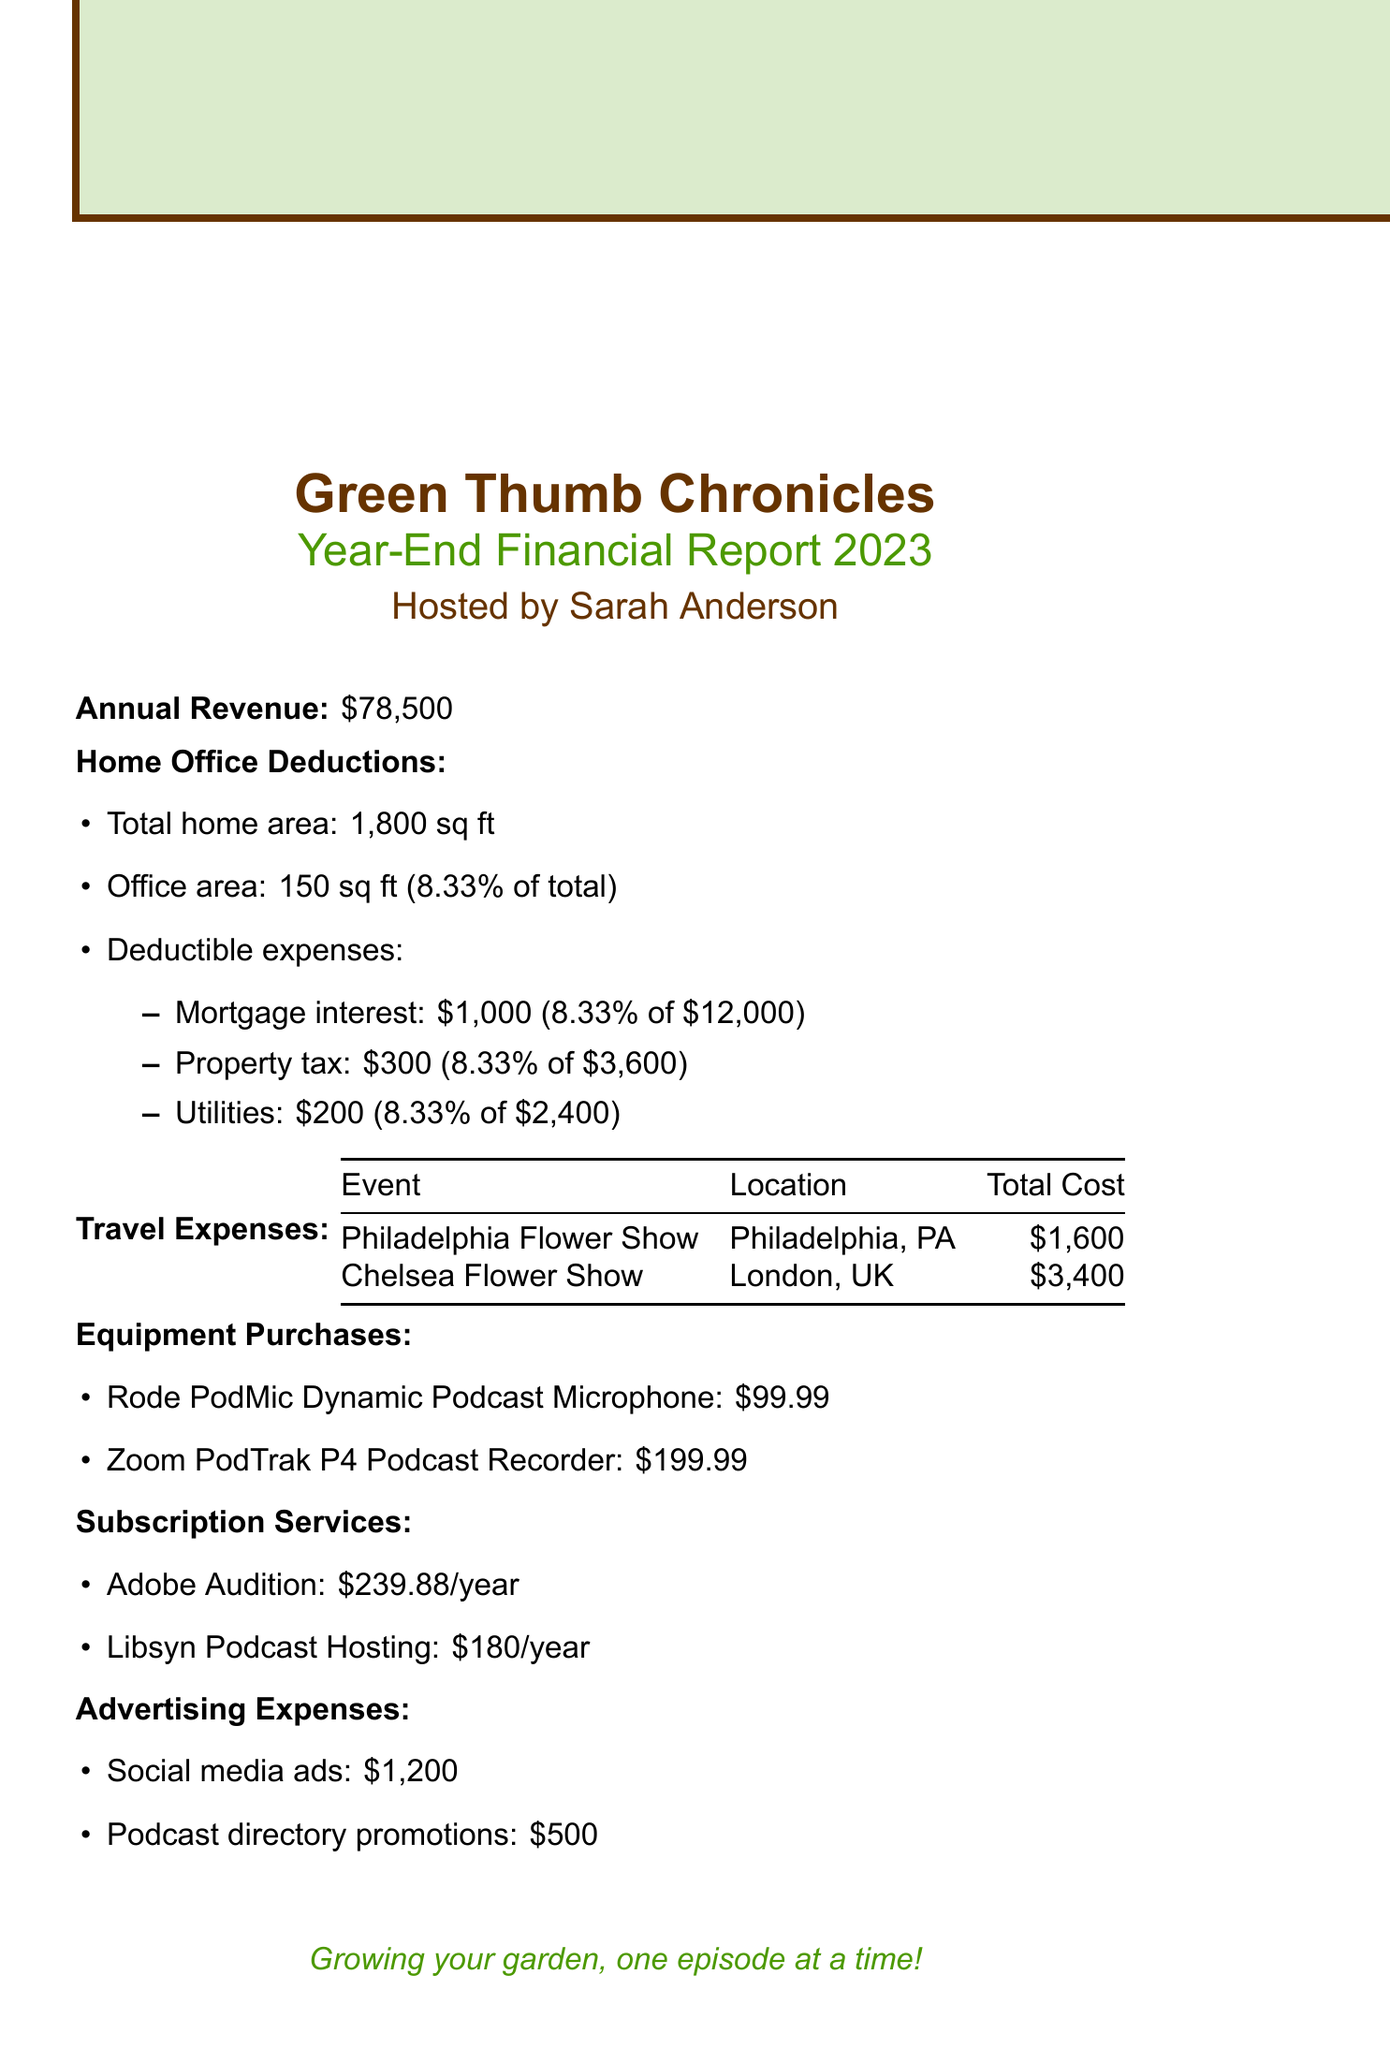What is the name of the podcast? The name of the podcast is stated at the beginning of the document under the header.
Answer: Green Thumb Chronicles What was the annual revenue for 2023? The annual revenue is explicitly listed in the financial report.
Answer: $78,500 What percentage of the total home area is the office area? The document specifies the total area and the office area, and calculates the percentage.
Answer: 8.33% How much was spent on airfare for the Chelsea Flower Show? The airfare expense for the Chelsea Flower Show is given in the travel expenses section.
Answer: $1,200 What are the total travel expenses for the Philadelphia Flower Show? The document lists individual expenses and provides a total cost for the event.
Answer: $1,600 How much did the podcast spend on the Rode PodMic? The cost of the Rode PodMic is mentioned in the equipment purchases.
Answer: $99.99 What is the total cost of annual subscription services? The document specifies individual annual costs, which must be summed to find the total.
Answer: $419.88 What is the total amount spent on advertising expenses? Advertising expenses for social media ads and directory promotions are listed, which need to be added together.
Answer: $1,700 Which month did the Philadelphia Flower Show occur? The event dates for the Philadelphia Flower Show are provided in the travel expenses section.
Answer: March 